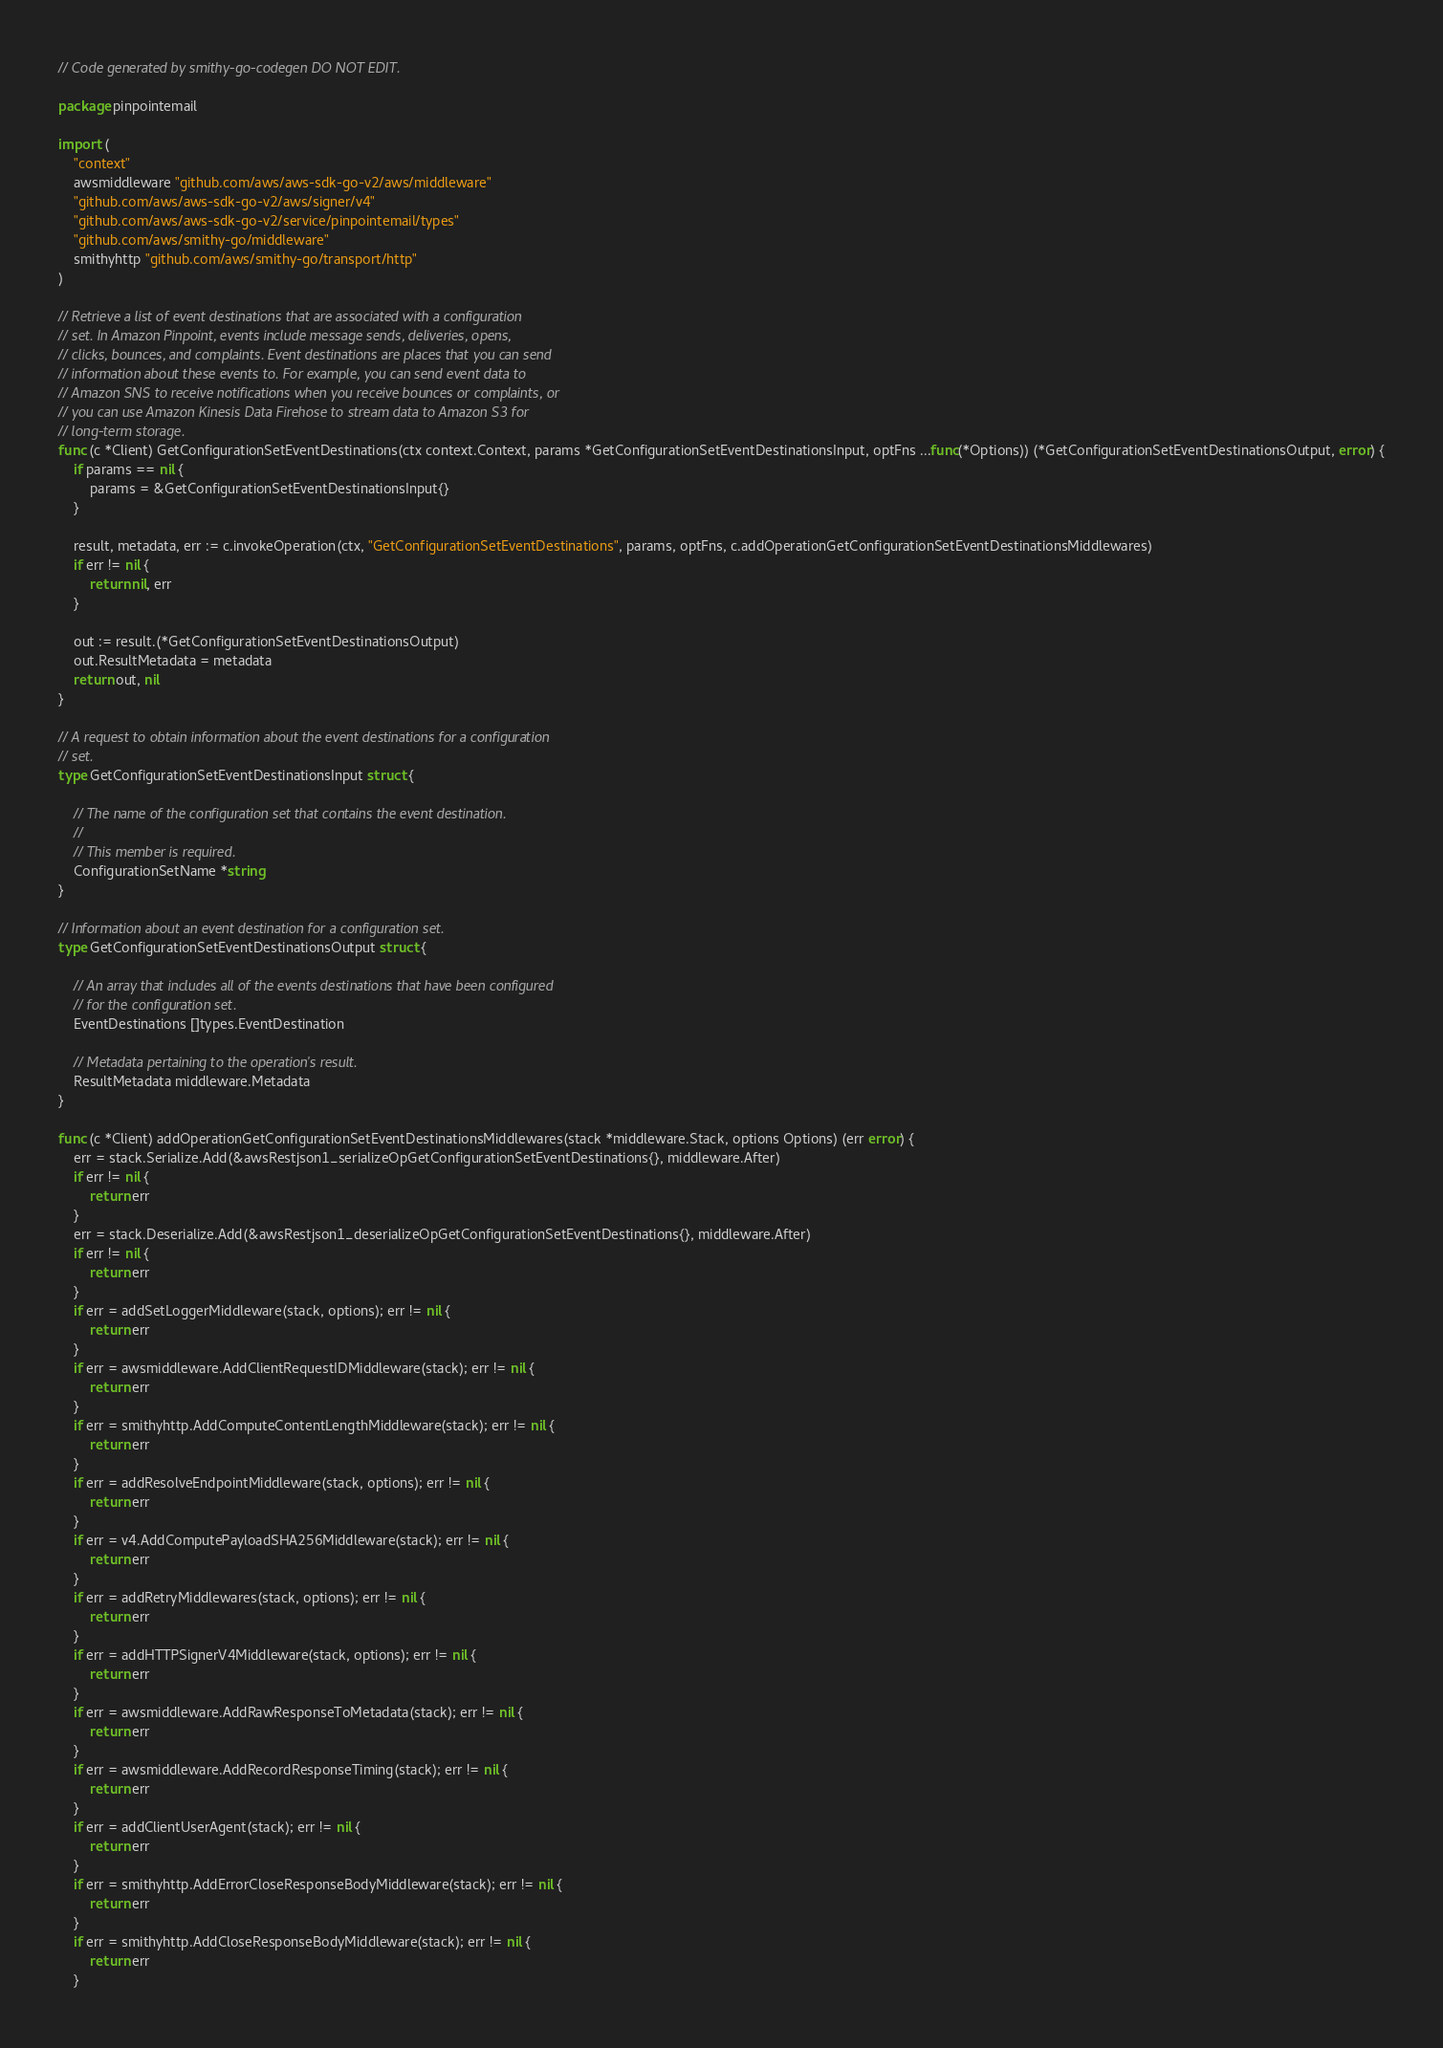Convert code to text. <code><loc_0><loc_0><loc_500><loc_500><_Go_>// Code generated by smithy-go-codegen DO NOT EDIT.

package pinpointemail

import (
	"context"
	awsmiddleware "github.com/aws/aws-sdk-go-v2/aws/middleware"
	"github.com/aws/aws-sdk-go-v2/aws/signer/v4"
	"github.com/aws/aws-sdk-go-v2/service/pinpointemail/types"
	"github.com/aws/smithy-go/middleware"
	smithyhttp "github.com/aws/smithy-go/transport/http"
)

// Retrieve a list of event destinations that are associated with a configuration
// set. In Amazon Pinpoint, events include message sends, deliveries, opens,
// clicks, bounces, and complaints. Event destinations are places that you can send
// information about these events to. For example, you can send event data to
// Amazon SNS to receive notifications when you receive bounces or complaints, or
// you can use Amazon Kinesis Data Firehose to stream data to Amazon S3 for
// long-term storage.
func (c *Client) GetConfigurationSetEventDestinations(ctx context.Context, params *GetConfigurationSetEventDestinationsInput, optFns ...func(*Options)) (*GetConfigurationSetEventDestinationsOutput, error) {
	if params == nil {
		params = &GetConfigurationSetEventDestinationsInput{}
	}

	result, metadata, err := c.invokeOperation(ctx, "GetConfigurationSetEventDestinations", params, optFns, c.addOperationGetConfigurationSetEventDestinationsMiddlewares)
	if err != nil {
		return nil, err
	}

	out := result.(*GetConfigurationSetEventDestinationsOutput)
	out.ResultMetadata = metadata
	return out, nil
}

// A request to obtain information about the event destinations for a configuration
// set.
type GetConfigurationSetEventDestinationsInput struct {

	// The name of the configuration set that contains the event destination.
	//
	// This member is required.
	ConfigurationSetName *string
}

// Information about an event destination for a configuration set.
type GetConfigurationSetEventDestinationsOutput struct {

	// An array that includes all of the events destinations that have been configured
	// for the configuration set.
	EventDestinations []types.EventDestination

	// Metadata pertaining to the operation's result.
	ResultMetadata middleware.Metadata
}

func (c *Client) addOperationGetConfigurationSetEventDestinationsMiddlewares(stack *middleware.Stack, options Options) (err error) {
	err = stack.Serialize.Add(&awsRestjson1_serializeOpGetConfigurationSetEventDestinations{}, middleware.After)
	if err != nil {
		return err
	}
	err = stack.Deserialize.Add(&awsRestjson1_deserializeOpGetConfigurationSetEventDestinations{}, middleware.After)
	if err != nil {
		return err
	}
	if err = addSetLoggerMiddleware(stack, options); err != nil {
		return err
	}
	if err = awsmiddleware.AddClientRequestIDMiddleware(stack); err != nil {
		return err
	}
	if err = smithyhttp.AddComputeContentLengthMiddleware(stack); err != nil {
		return err
	}
	if err = addResolveEndpointMiddleware(stack, options); err != nil {
		return err
	}
	if err = v4.AddComputePayloadSHA256Middleware(stack); err != nil {
		return err
	}
	if err = addRetryMiddlewares(stack, options); err != nil {
		return err
	}
	if err = addHTTPSignerV4Middleware(stack, options); err != nil {
		return err
	}
	if err = awsmiddleware.AddRawResponseToMetadata(stack); err != nil {
		return err
	}
	if err = awsmiddleware.AddRecordResponseTiming(stack); err != nil {
		return err
	}
	if err = addClientUserAgent(stack); err != nil {
		return err
	}
	if err = smithyhttp.AddErrorCloseResponseBodyMiddleware(stack); err != nil {
		return err
	}
	if err = smithyhttp.AddCloseResponseBodyMiddleware(stack); err != nil {
		return err
	}</code> 